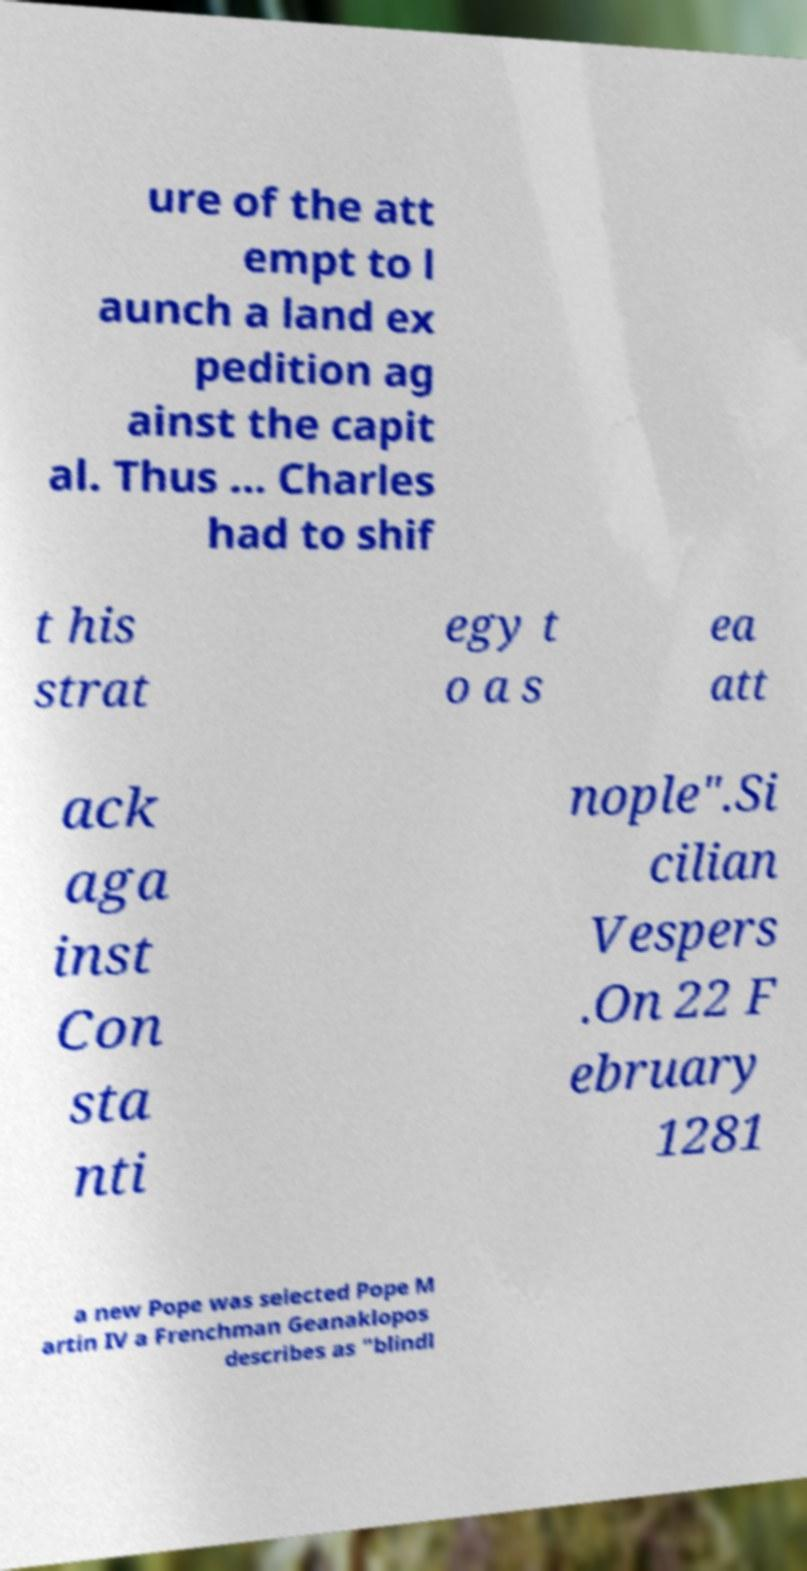I need the written content from this picture converted into text. Can you do that? ure of the att empt to l aunch a land ex pedition ag ainst the capit al. Thus ... Charles had to shif t his strat egy t o a s ea att ack aga inst Con sta nti nople".Si cilian Vespers .On 22 F ebruary 1281 a new Pope was selected Pope M artin IV a Frenchman Geanaklopos describes as "blindl 